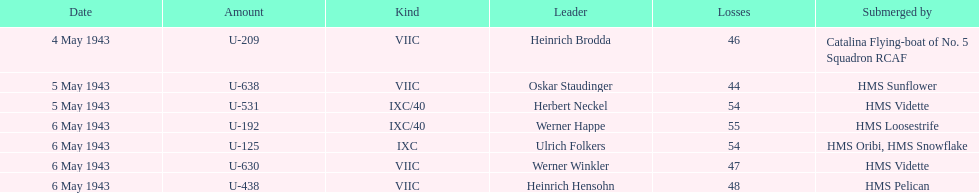What was the casualty count on may 4, 1943? 46. 